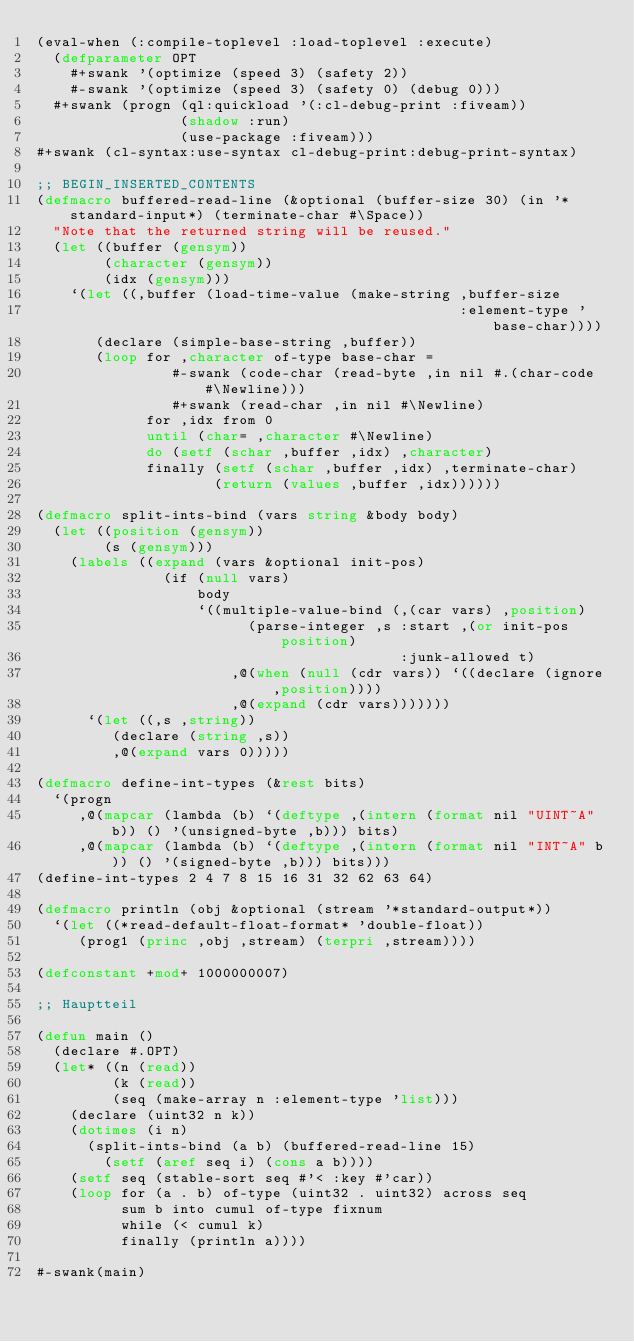<code> <loc_0><loc_0><loc_500><loc_500><_Lisp_>(eval-when (:compile-toplevel :load-toplevel :execute)
  (defparameter OPT
    #+swank '(optimize (speed 3) (safety 2))
    #-swank '(optimize (speed 3) (safety 0) (debug 0)))
  #+swank (progn (ql:quickload '(:cl-debug-print :fiveam))
                 (shadow :run)
                 (use-package :fiveam)))
#+swank (cl-syntax:use-syntax cl-debug-print:debug-print-syntax)

;; BEGIN_INSERTED_CONTENTS
(defmacro buffered-read-line (&optional (buffer-size 30) (in '*standard-input*) (terminate-char #\Space))
  "Note that the returned string will be reused."
  (let ((buffer (gensym))
        (character (gensym))
        (idx (gensym)))
    `(let ((,buffer (load-time-value (make-string ,buffer-size
                                                  :element-type 'base-char))))
       (declare (simple-base-string ,buffer))
       (loop for ,character of-type base-char =
                #-swank (code-char (read-byte ,in nil #.(char-code #\Newline)))
                #+swank (read-char ,in nil #\Newline)
             for ,idx from 0
             until (char= ,character #\Newline)
             do (setf (schar ,buffer ,idx) ,character)
             finally (setf (schar ,buffer ,idx) ,terminate-char)
                     (return (values ,buffer ,idx))))))

(defmacro split-ints-bind (vars string &body body)
  (let ((position (gensym))
        (s (gensym)))
    (labels ((expand (vars &optional init-pos)
               (if (null vars)
                   body
                   `((multiple-value-bind (,(car vars) ,position)
                         (parse-integer ,s :start ,(or init-pos position)
                                           :junk-allowed t)
                       ,@(when (null (cdr vars)) `((declare (ignore ,position))))
                       ,@(expand (cdr vars)))))))
      `(let ((,s ,string))
         (declare (string ,s))
         ,@(expand vars 0)))))

(defmacro define-int-types (&rest bits)
  `(progn
     ,@(mapcar (lambda (b) `(deftype ,(intern (format nil "UINT~A" b)) () '(unsigned-byte ,b))) bits)
     ,@(mapcar (lambda (b) `(deftype ,(intern (format nil "INT~A" b)) () '(signed-byte ,b))) bits)))
(define-int-types 2 4 7 8 15 16 31 32 62 63 64)

(defmacro println (obj &optional (stream '*standard-output*))
  `(let ((*read-default-float-format* 'double-float))
     (prog1 (princ ,obj ,stream) (terpri ,stream))))

(defconstant +mod+ 1000000007)

;; Hauptteil

(defun main ()
  (declare #.OPT)
  (let* ((n (read))
         (k (read))
         (seq (make-array n :element-type 'list)))
    (declare (uint32 n k))
    (dotimes (i n)
      (split-ints-bind (a b) (buffered-read-line 15)
        (setf (aref seq i) (cons a b))))
    (setf seq (stable-sort seq #'< :key #'car))
    (loop for (a . b) of-type (uint32 . uint32) across seq
          sum b into cumul of-type fixnum
          while (< cumul k)
          finally (println a))))

#-swank(main)
</code> 